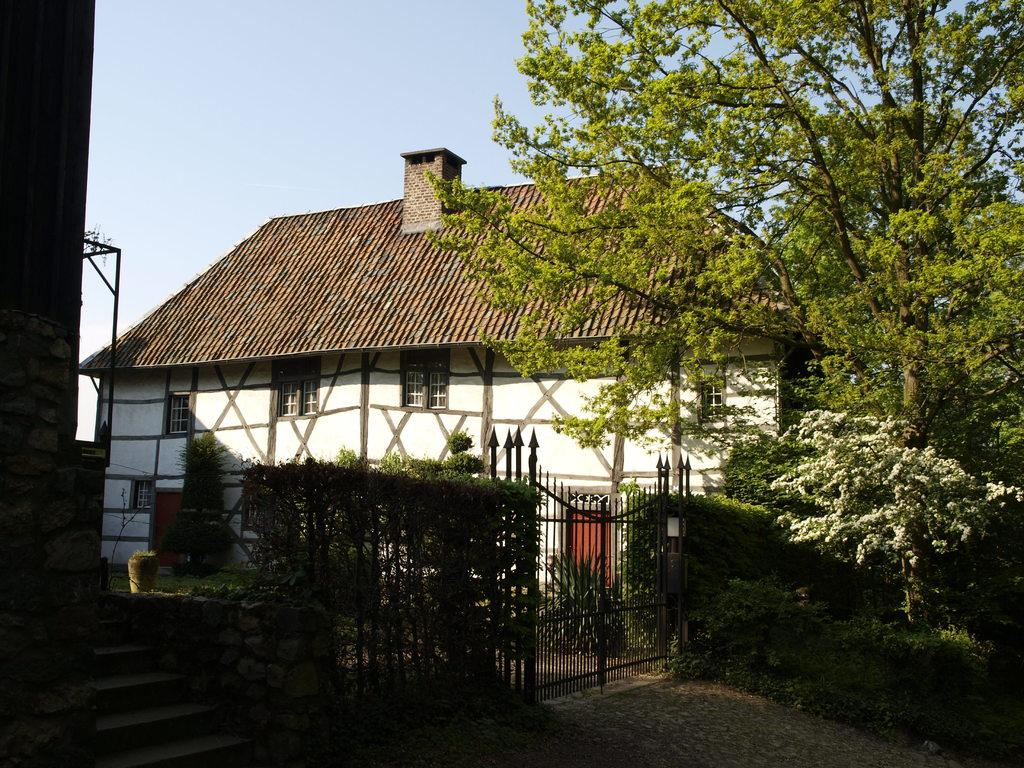What is the main subject in the middle of the image? There is a house in the middle of the image. What type of vegetation is on the right side of the image? There are trees on the right side of the image. Can you see a bear sneezing in the image? No, there is no bear or sneezing in the image. Is there any bread visible in the image? No, there is no bread present in the image. 